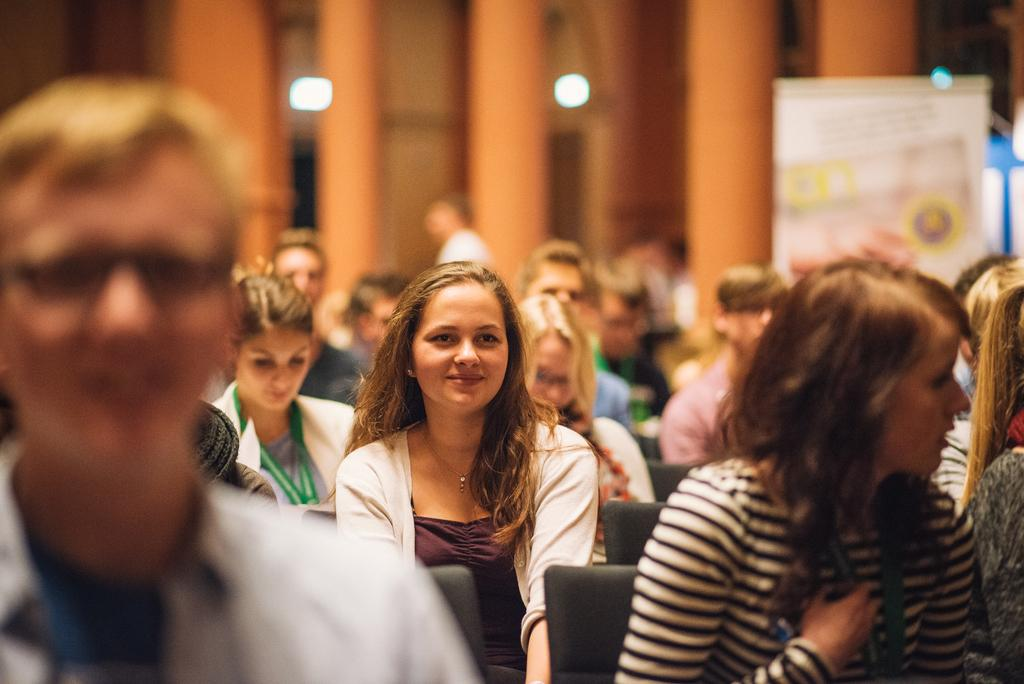What are the people in the image doing? The people in the image are sitting on chairs. What can be seen on the right side of the image? There is a board on the right side of the image. What architectural features are present in the image? There are pillars in the image. What is attached to the wall in the background of the image? There is a wall with lights attached to it in the background of the image. What type of fuel is being used by the brain in the image? There is no brain or fuel present in the image. What kind of stone is visible in the image? There is no stone visible in the image. 